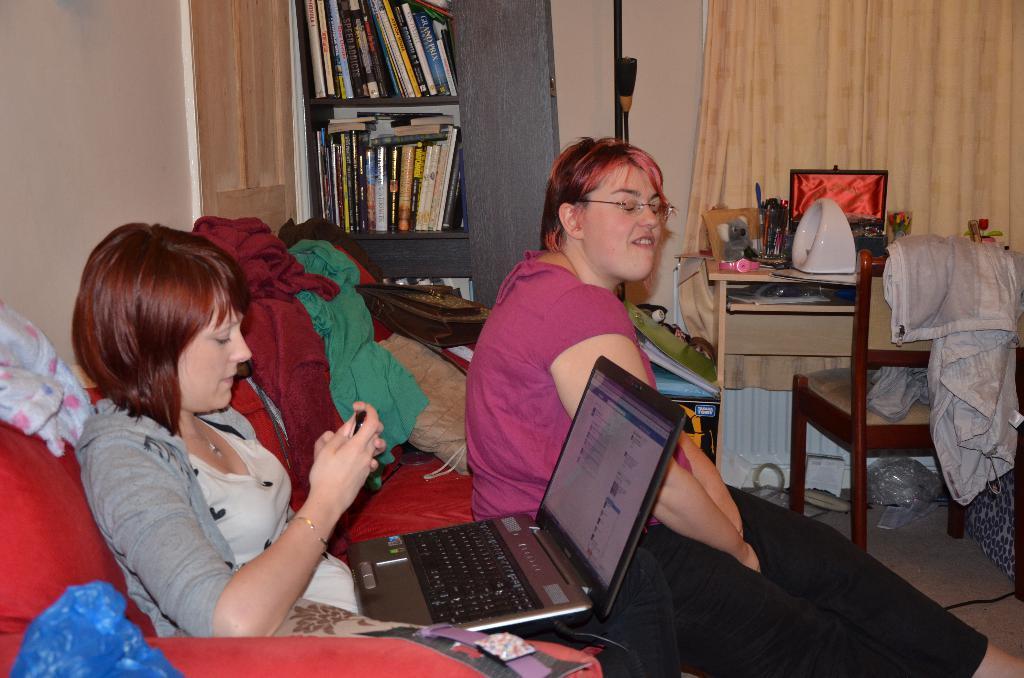In one or two sentences, can you explain what this image depicts? 2 people are sitting in a room. There is a laptop, clothes, books in the shelves, a table, a chair and curtains at the back. 